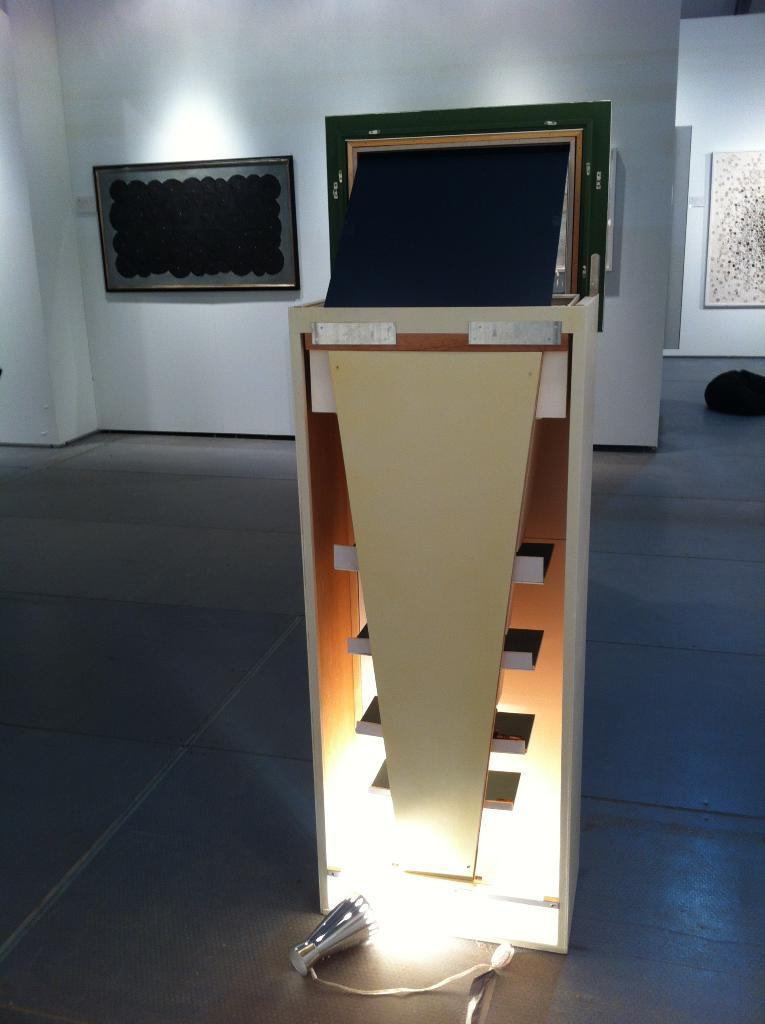What is the main object in the image? There is a stand in the image. What is located near the stand? There is a light on the floor near the stand. What can be seen in the background of the image? There is a wall with a photo frame in the background. How does the sleet affect the stand in the image? There is no mention of sleet in the image, so it cannot be determined how it would affect the stand. 